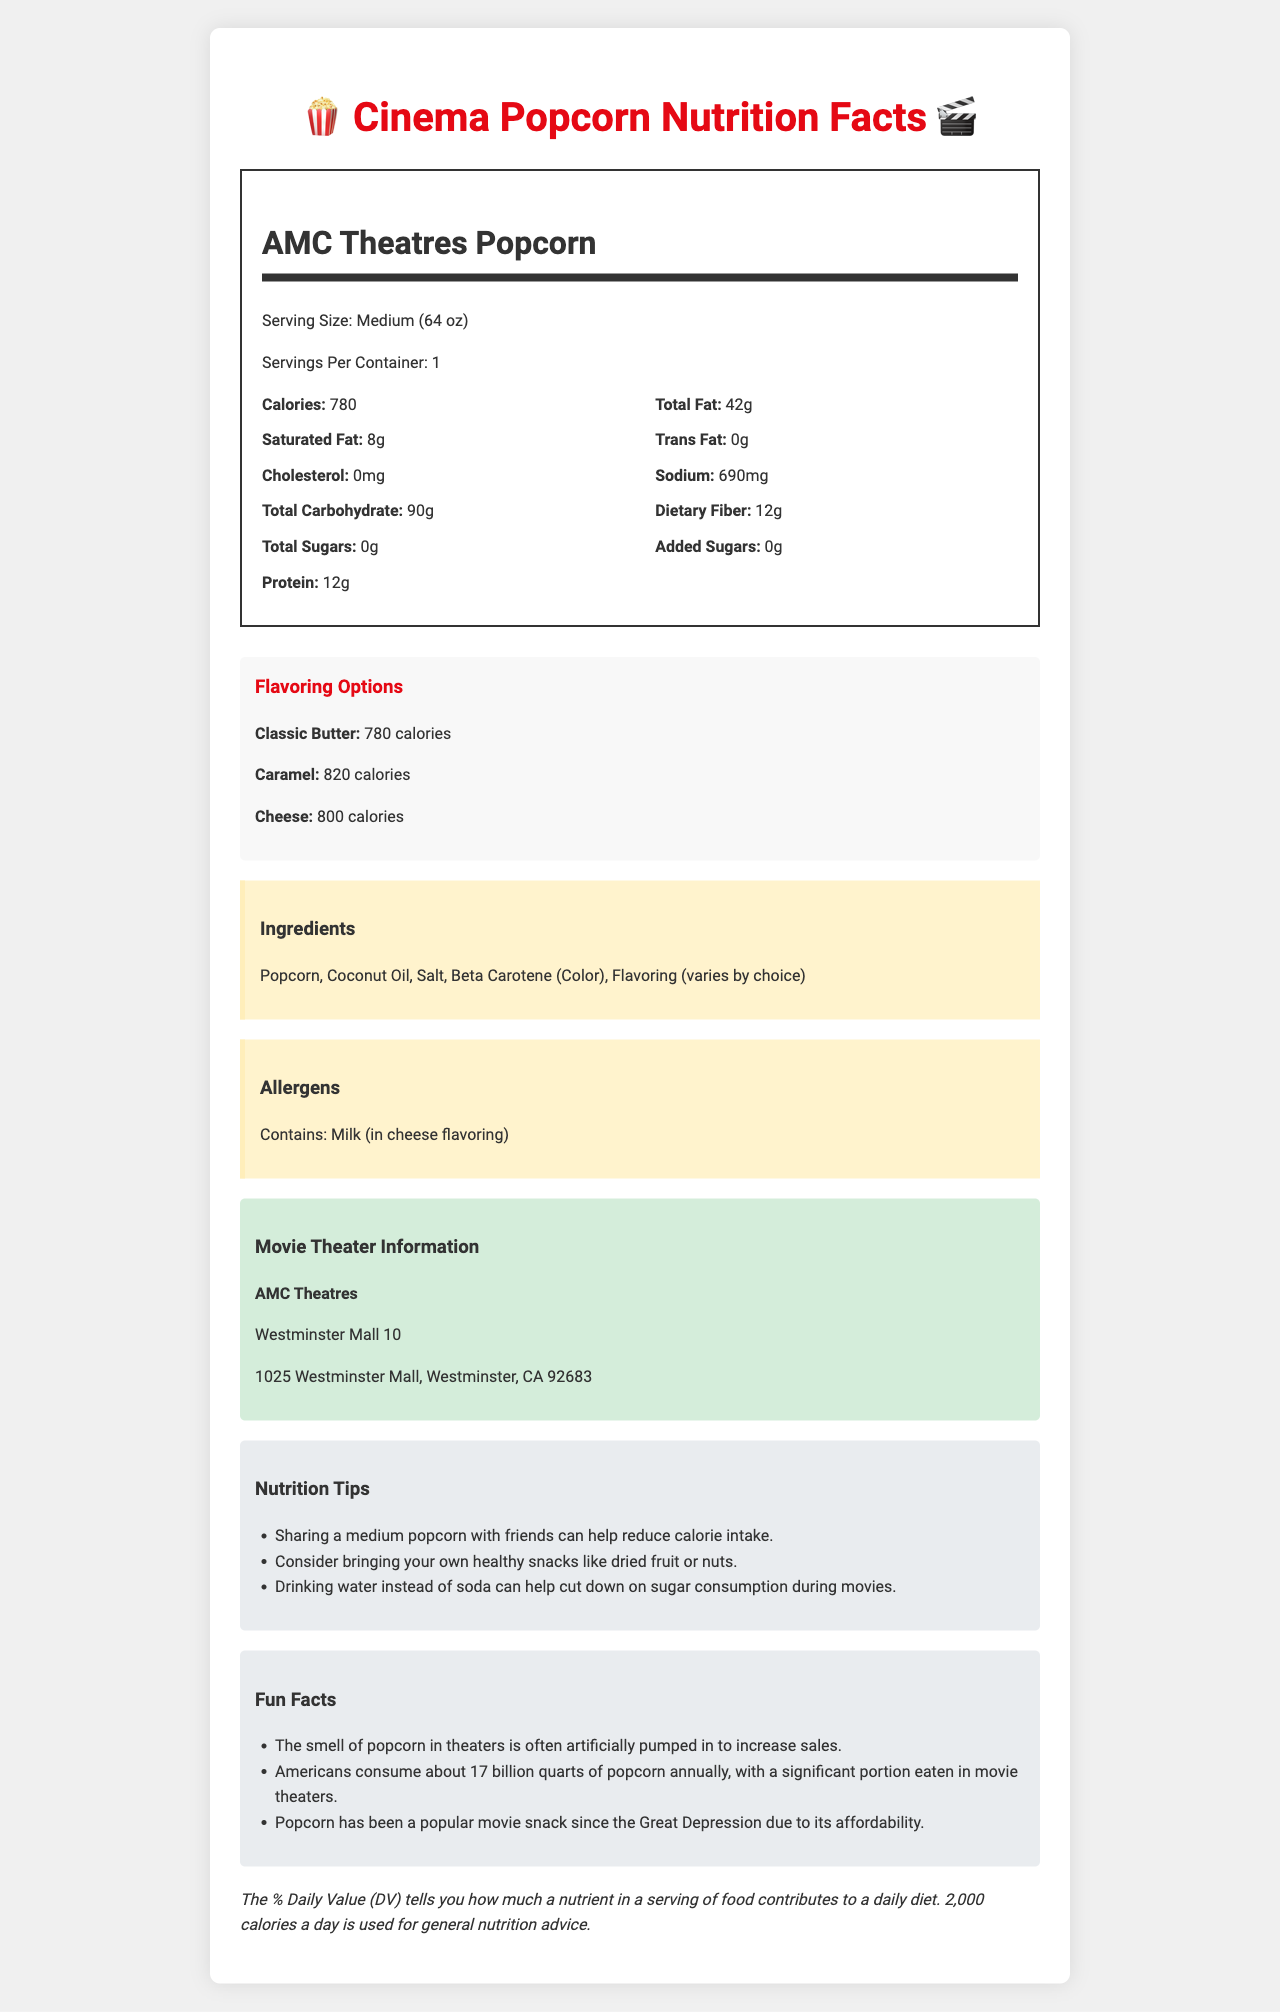What is the serving size of AMC Theatres Popcorn? The document specifies that the serving size is "Medium (64 oz)."
Answer: Medium (64 oz) How many calories are in the Classic Butter flavor of AMC Theatres Popcorn? The document lists the calories for the Classic Butter flavor as 780.
Answer: 780 calories What ingredients are used in AMC Theatres Popcorn? The ingredients are specifically mentioned in a section labeled "Ingredients."
Answer: Popcorn, Coconut Oil, Salt, Beta Carotene (Color), Flavoring (varies by choice) What is the amount of dietary fiber in the Cheese flavored popcorn? The document lists 11 grams of dietary fiber for the Cheese flavor.
Answer: 11 grams Which flavor of AMC Theatres Popcorn contains the most sodium? The Cheese flavor has 980 mg of sodium, which is the highest among the listed flavors.
Answer: Cheese What is the main difference between the added sugars in the Classic Butter and Caramel flavors? The document lists 25 grams of added sugars for the Caramel flavor and 0 grams for the Classic Butter flavor.
Answer: The Caramel flavor has 25 grams of added sugars, while the Classic Butter flavor has 0 grams of added sugars. Which flavor of AMC Theatres Popcorn has the highest amount of protein? A. Classic Butter B. Caramel C. Cheese The Cheese flavor has 15 grams of protein compared to the Classic Butter's 12 grams and Caramel's 10 grams.
Answer: C What is the address of the AMC Theatres location mentioned in the document? The document specifies this address under the "Movie Theater Information" section.
Answer: 1025 Westminster Mall, Westminster, CA 92683 Which of the following is not listed as an allergen in the document? A. Milk B. Peanuts C. Soy The document only lists "Contains: Milk (in cheese flavoring)" as an allergen but does not mention peanuts or soy.
Answer: B Can sharing a medium popcorn with friends reduce calorie intake? The document provides a nutrition tip that states sharing a medium popcorn with friends can help reduce calorie intake.
Answer: Yes Summarize the key nutritional information and tips provided in the document. The summary covers the main content of the document, breaking down the nutritional facts and other relevant information.
Answer: The document provides nutritional details for AMC Theatres Popcorn with three flavor options: Classic Butter, Caramel, and Cheese. It includes calorie counts, amounts of fat, sodium, carbohydrates, and protein for each flavor. Additionally, it lists ingredients, allergens, and several nutrition tips to help reduce calorie and sugar intake while enjoying popcorn at the movie theater. What are the average monthly sales for each flavor of AMC Theatres Popcorn? The document does not provide any sales data or figures, only nutritional and ingredient information.
Answer: Not enough information 